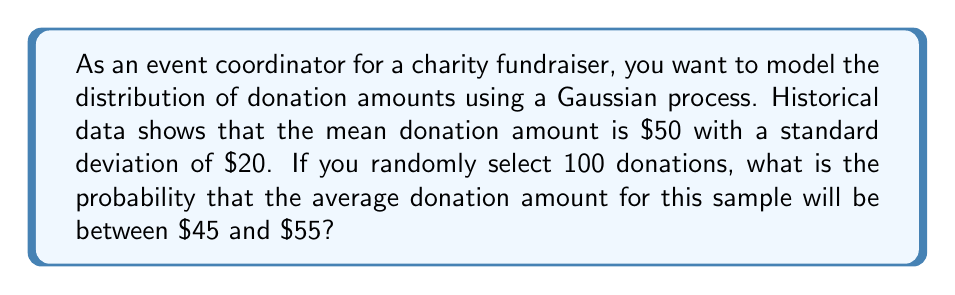Show me your answer to this math problem. Let's approach this step-by-step:

1) We are dealing with a sample mean, so we need to use the Central Limit Theorem.

2) The Central Limit Theorem states that for a large sample size (n ≥ 30), the sampling distribution of the mean is approximately normal, regardless of the underlying distribution of the population.

3) Given:
   - Population mean (μ) = $50
   - Population standard deviation (σ) = $20
   - Sample size (n) = 100

4) The standard error of the mean is:
   $$SE_{\bar{X}} = \frac{\sigma}{\sqrt{n}} = \frac{20}{\sqrt{100}} = 2$$

5) The sampling distribution of the mean will be normally distributed with:
   Mean = μ = $50
   Standard deviation = $2

6) We want to find P($45 < \bar{X} < $55)

7) Standardizing these values:
   $$z_1 = \frac{45 - 50}{2} = -2.5$$
   $$z_2 = \frac{55 - 50}{2} = 2.5$$

8) We need to find P(-2.5 < Z < 2.5)

9) Using the standard normal distribution table or a calculator:
   P(Z < 2.5) = 0.9938
   P(Z < -2.5) = 0.0062

10) Therefore, P(-2.5 < Z < 2.5) = 0.9938 - 0.0062 = 0.9876
Answer: 0.9876 